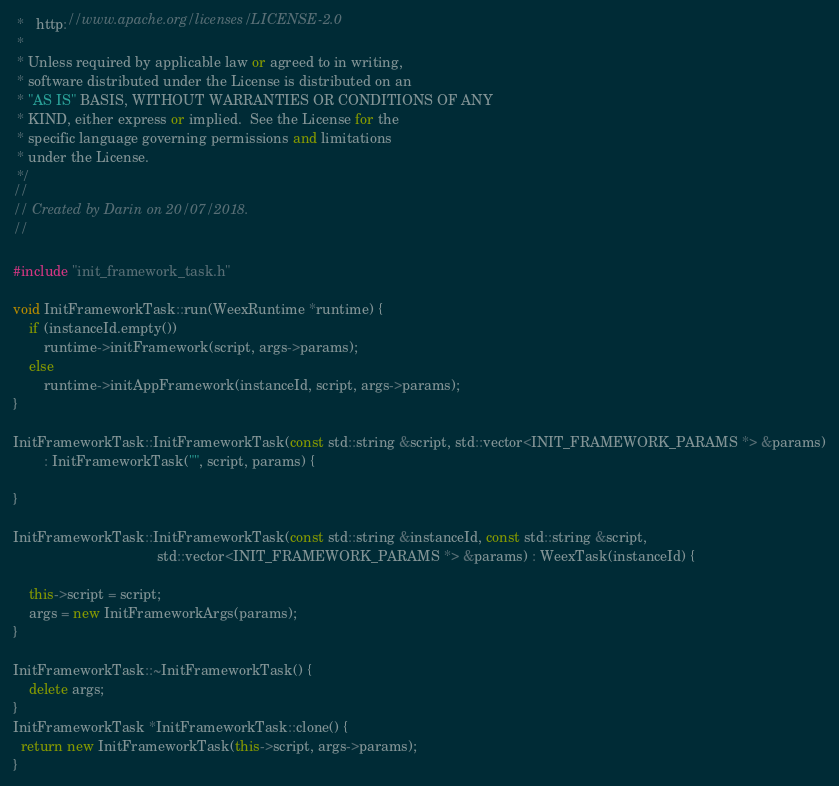Convert code to text. <code><loc_0><loc_0><loc_500><loc_500><_C++_> *   http://www.apache.org/licenses/LICENSE-2.0
 *
 * Unless required by applicable law or agreed to in writing,
 * software distributed under the License is distributed on an
 * "AS IS" BASIS, WITHOUT WARRANTIES OR CONDITIONS OF ANY
 * KIND, either express or implied.  See the License for the
 * specific language governing permissions and limitations
 * under the License.
 */
//
// Created by Darin on 20/07/2018.
//

#include "init_framework_task.h"

void InitFrameworkTask::run(WeexRuntime *runtime) {
    if (instanceId.empty())
        runtime->initFramework(script, args->params);
    else
        runtime->initAppFramework(instanceId, script, args->params);
}

InitFrameworkTask::InitFrameworkTask(const std::string &script, std::vector<INIT_FRAMEWORK_PARAMS *> &params)
        : InitFrameworkTask("", script, params) {

}

InitFrameworkTask::InitFrameworkTask(const std::string &instanceId, const std::string &script,
                                     std::vector<INIT_FRAMEWORK_PARAMS *> &params) : WeexTask(instanceId) {

    this->script = script;
    args = new InitFrameworkArgs(params);
}

InitFrameworkTask::~InitFrameworkTask() {
    delete args;
}
InitFrameworkTask *InitFrameworkTask::clone() {
  return new InitFrameworkTask(this->script, args->params);
}
</code> 